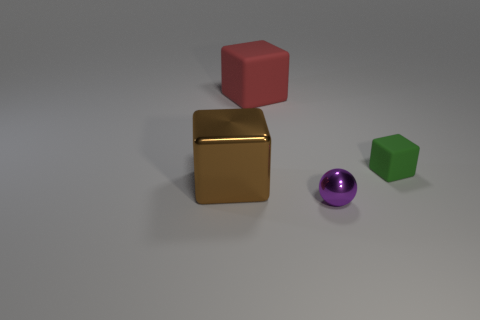Subtract all matte cubes. How many cubes are left? 1 Subtract all spheres. How many objects are left? 3 Subtract all green blocks. Subtract all yellow balls. How many blocks are left? 2 Subtract all brown cylinders. How many green cubes are left? 1 Subtract all large cyan rubber cylinders. Subtract all tiny metal things. How many objects are left? 3 Add 3 brown things. How many brown things are left? 4 Add 1 small green matte balls. How many small green matte balls exist? 1 Add 2 big metal things. How many objects exist? 6 Subtract all red cubes. How many cubes are left? 2 Subtract 0 purple cylinders. How many objects are left? 4 